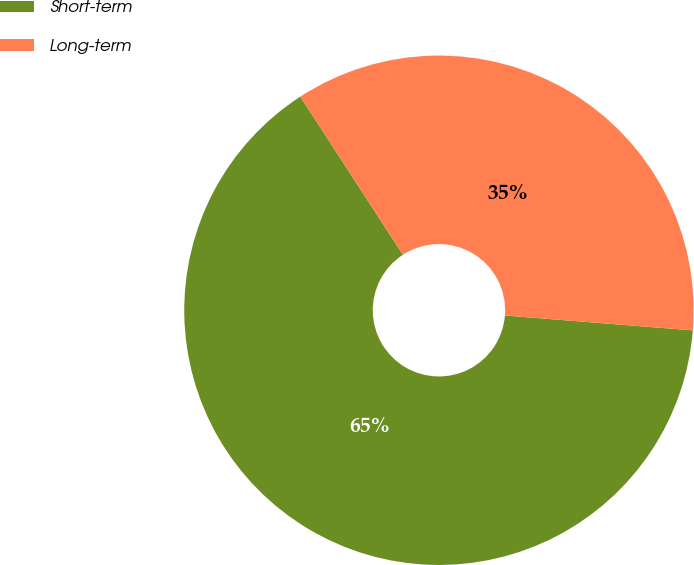Convert chart. <chart><loc_0><loc_0><loc_500><loc_500><pie_chart><fcel>Short-term<fcel>Long-term<nl><fcel>64.58%<fcel>35.42%<nl></chart> 